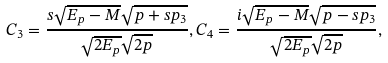<formula> <loc_0><loc_0><loc_500><loc_500>C _ { 3 } = \frac { s \sqrt { E _ { p } - M } \sqrt { p + s p _ { 3 } } } { \sqrt { 2 E _ { p } } \sqrt { 2 p } } , C _ { 4 } = \frac { i \sqrt { E _ { p } - M } \sqrt { p - s p _ { 3 } } } { \sqrt { 2 E _ { p } } \sqrt { 2 p } } ,</formula> 